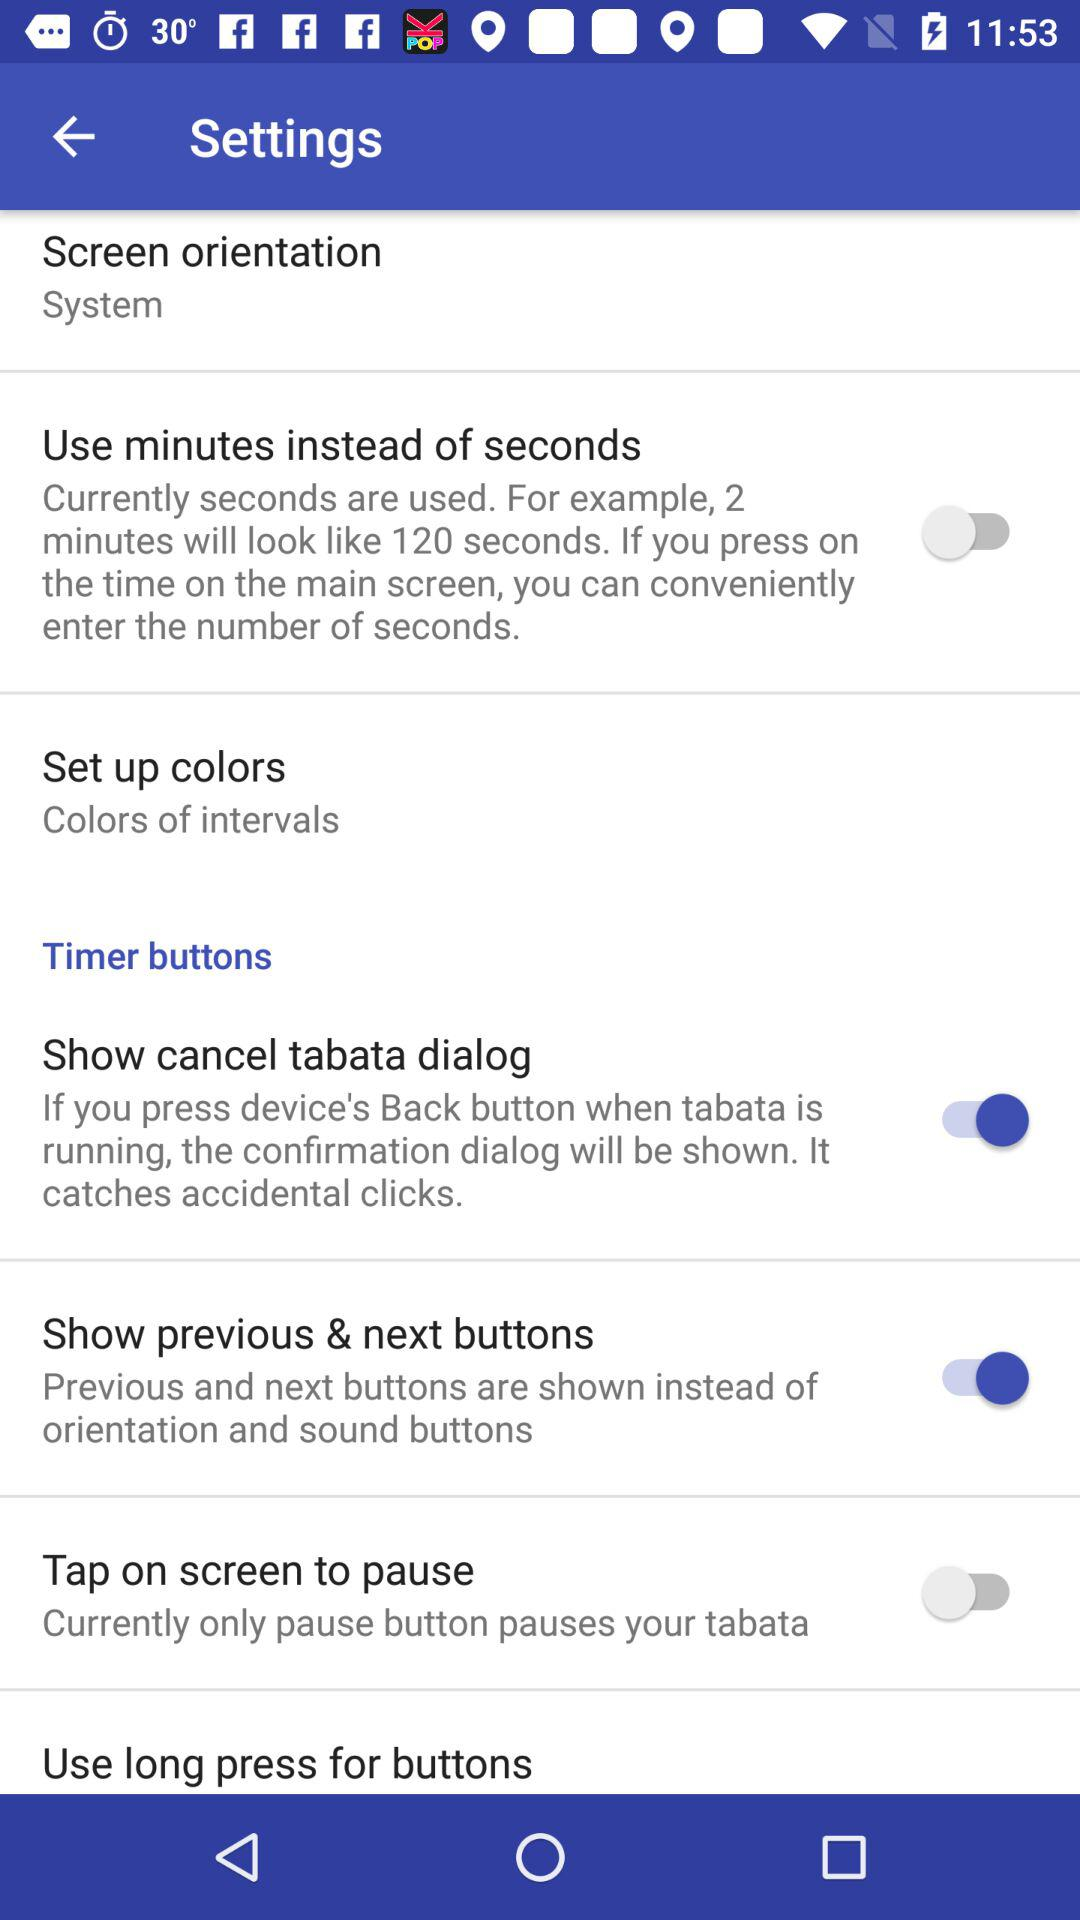What is the status of the "Use minutes instead of seconds" settings? The status of the "Use minutes instead of seconds" settings is "off". 